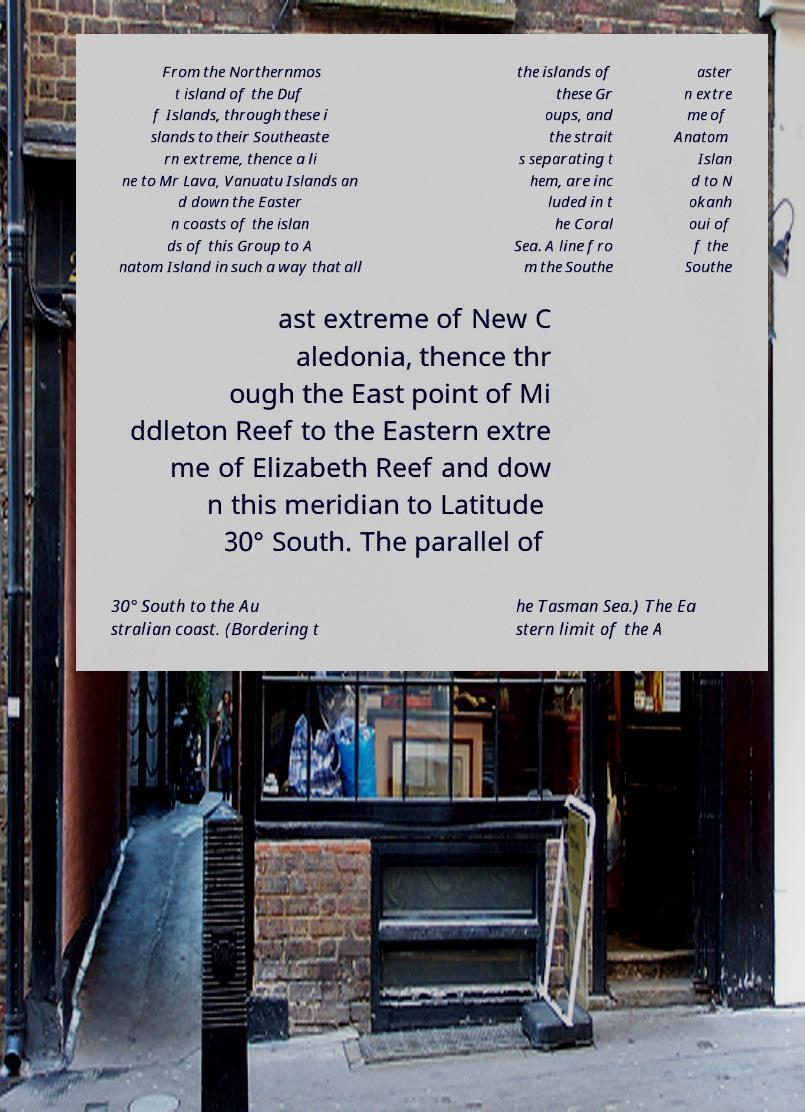Could you assist in decoding the text presented in this image and type it out clearly? From the Northernmos t island of the Duf f Islands, through these i slands to their Southeaste rn extreme, thence a li ne to Mr Lava, Vanuatu Islands an d down the Easter n coasts of the islan ds of this Group to A natom Island in such a way that all the islands of these Gr oups, and the strait s separating t hem, are inc luded in t he Coral Sea. A line fro m the Southe aster n extre me of Anatom Islan d to N okanh oui of f the Southe ast extreme of New C aledonia, thence thr ough the East point of Mi ddleton Reef to the Eastern extre me of Elizabeth Reef and dow n this meridian to Latitude 30° South. The parallel of 30° South to the Au stralian coast. (Bordering t he Tasman Sea.) The Ea stern limit of the A 